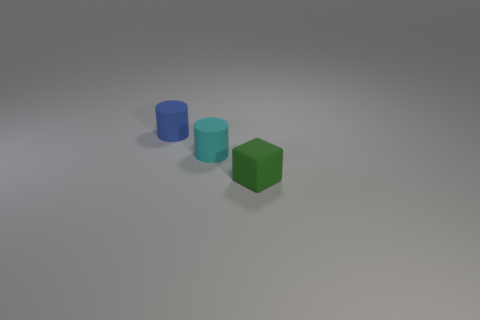Add 1 large red blocks. How many objects exist? 4 Subtract all blocks. How many objects are left? 2 Add 2 tiny cyan cylinders. How many tiny cyan cylinders are left? 3 Add 2 green rubber things. How many green rubber things exist? 3 Subtract 1 blue cylinders. How many objects are left? 2 Subtract all tiny matte objects. Subtract all large brown objects. How many objects are left? 0 